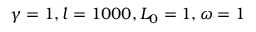Convert formula to latex. <formula><loc_0><loc_0><loc_500><loc_500>\gamma = 1 , l = 1 0 0 0 , L _ { 0 } = 1 , \omega = 1</formula> 